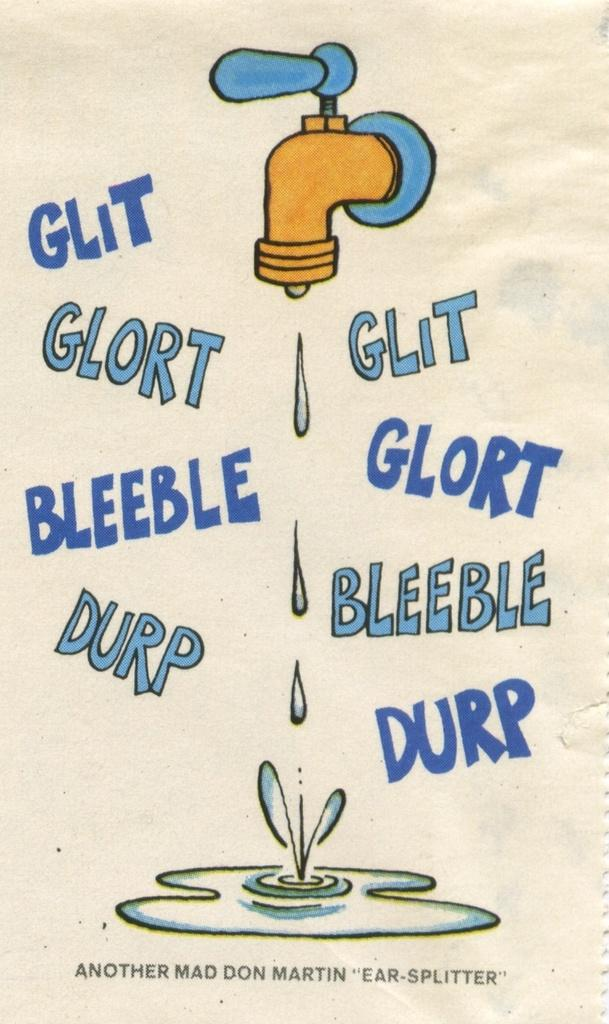<image>
Provide a brief description of the given image. a poster with a dripping faucet and the words "glit, glort, bleeble and durp" around it 